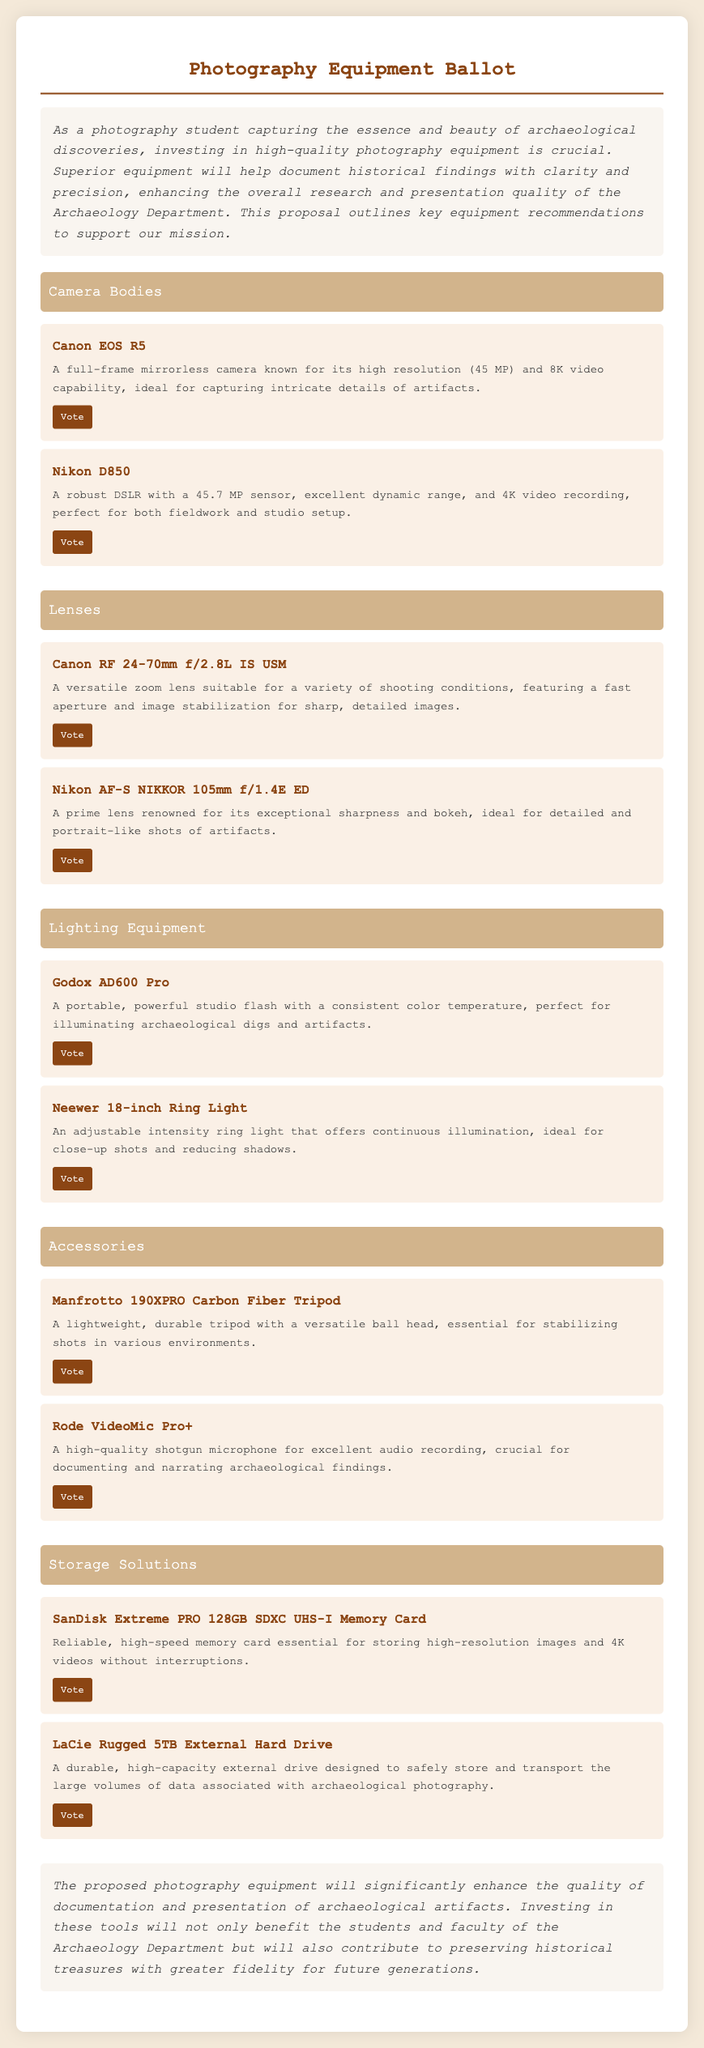What is the title of the ballot? The title of the ballot is prominently displayed at the top of the document, highlighting the purpose of the proposal.
Answer: Photography Equipment Ballot How many camera bodies are proposed? The document lists two camera body options that can be voted on.
Answer: Two What is the description of the Canon RF 24-70mm f/2.8L IS USM? The description for this lens can be found under the Lenses section, detailing its functionalities and suitability.
Answer: A versatile zoom lens suitable for a variety of shooting conditions, featuring a fast aperture and image stabilization for sharp, detailed images Which lighting equipment is known for its consistent color temperature? This information can be gathered from the Lighting Equipment section, indicating its role in the proposal.
Answer: Godox AD600 Pro What microphone is included in the Accessories section? A quick look at the Accessories section reveals the audio equipment proposed for purchase.
Answer: Rode VideoMic Pro+ What type of storage solution has a capacity of 5TB? The document details various storage solutions with specific capacities within the Storage Solutions section.
Answer: LaCie Rugged 5TB External Hard Drive What is the main goal of investing in new photography equipment? The introductory paragraph expresses the primary purpose of the proposal.
Answer: Enhance documentation quality How many items are proposed for the Lighting Equipment category? By counting the items listed under the respective category, this answer can be derived easily.
Answer: Two 